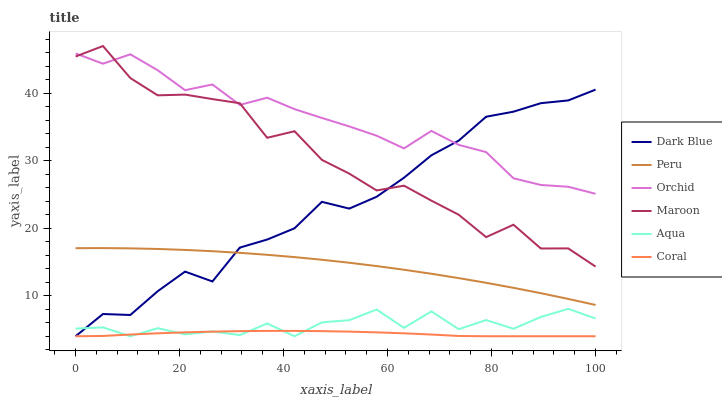Does Coral have the minimum area under the curve?
Answer yes or no. Yes. Does Orchid have the maximum area under the curve?
Answer yes or no. Yes. Does Aqua have the minimum area under the curve?
Answer yes or no. No. Does Aqua have the maximum area under the curve?
Answer yes or no. No. Is Coral the smoothest?
Answer yes or no. Yes. Is Maroon the roughest?
Answer yes or no. Yes. Is Aqua the smoothest?
Answer yes or no. No. Is Aqua the roughest?
Answer yes or no. No. Does Coral have the lowest value?
Answer yes or no. Yes. Does Maroon have the lowest value?
Answer yes or no. No. Does Maroon have the highest value?
Answer yes or no. Yes. Does Aqua have the highest value?
Answer yes or no. No. Is Coral less than Maroon?
Answer yes or no. Yes. Is Peru greater than Coral?
Answer yes or no. Yes. Does Coral intersect Dark Blue?
Answer yes or no. Yes. Is Coral less than Dark Blue?
Answer yes or no. No. Is Coral greater than Dark Blue?
Answer yes or no. No. Does Coral intersect Maroon?
Answer yes or no. No. 